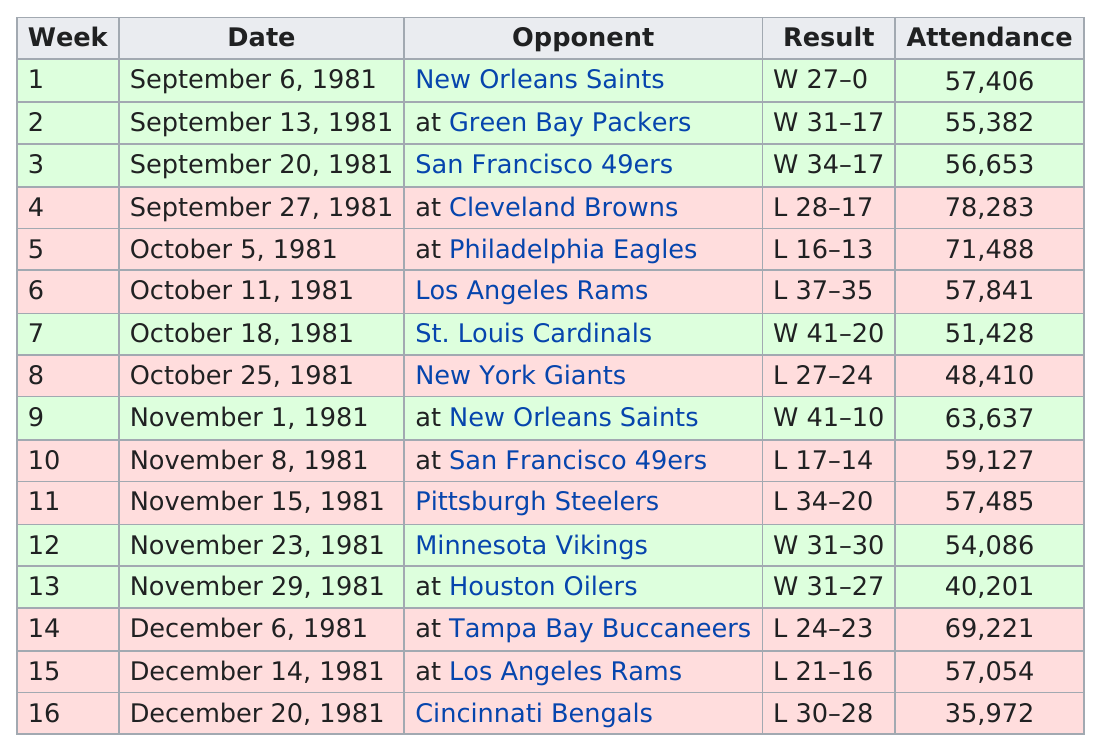Draw attention to some important aspects in this diagram. The Cincinnati Bengals played the last game of the 1981 season. The Atlanta Falcons won 7 games in the 1981 season. In 1981, the number of games between both Saints games was 7. During the 1981 Falcons season, only 13 points were scored, a record for the least amount of points scored in a single season. The home opener was attended by a record-breaking 57,406 passionate fans! 